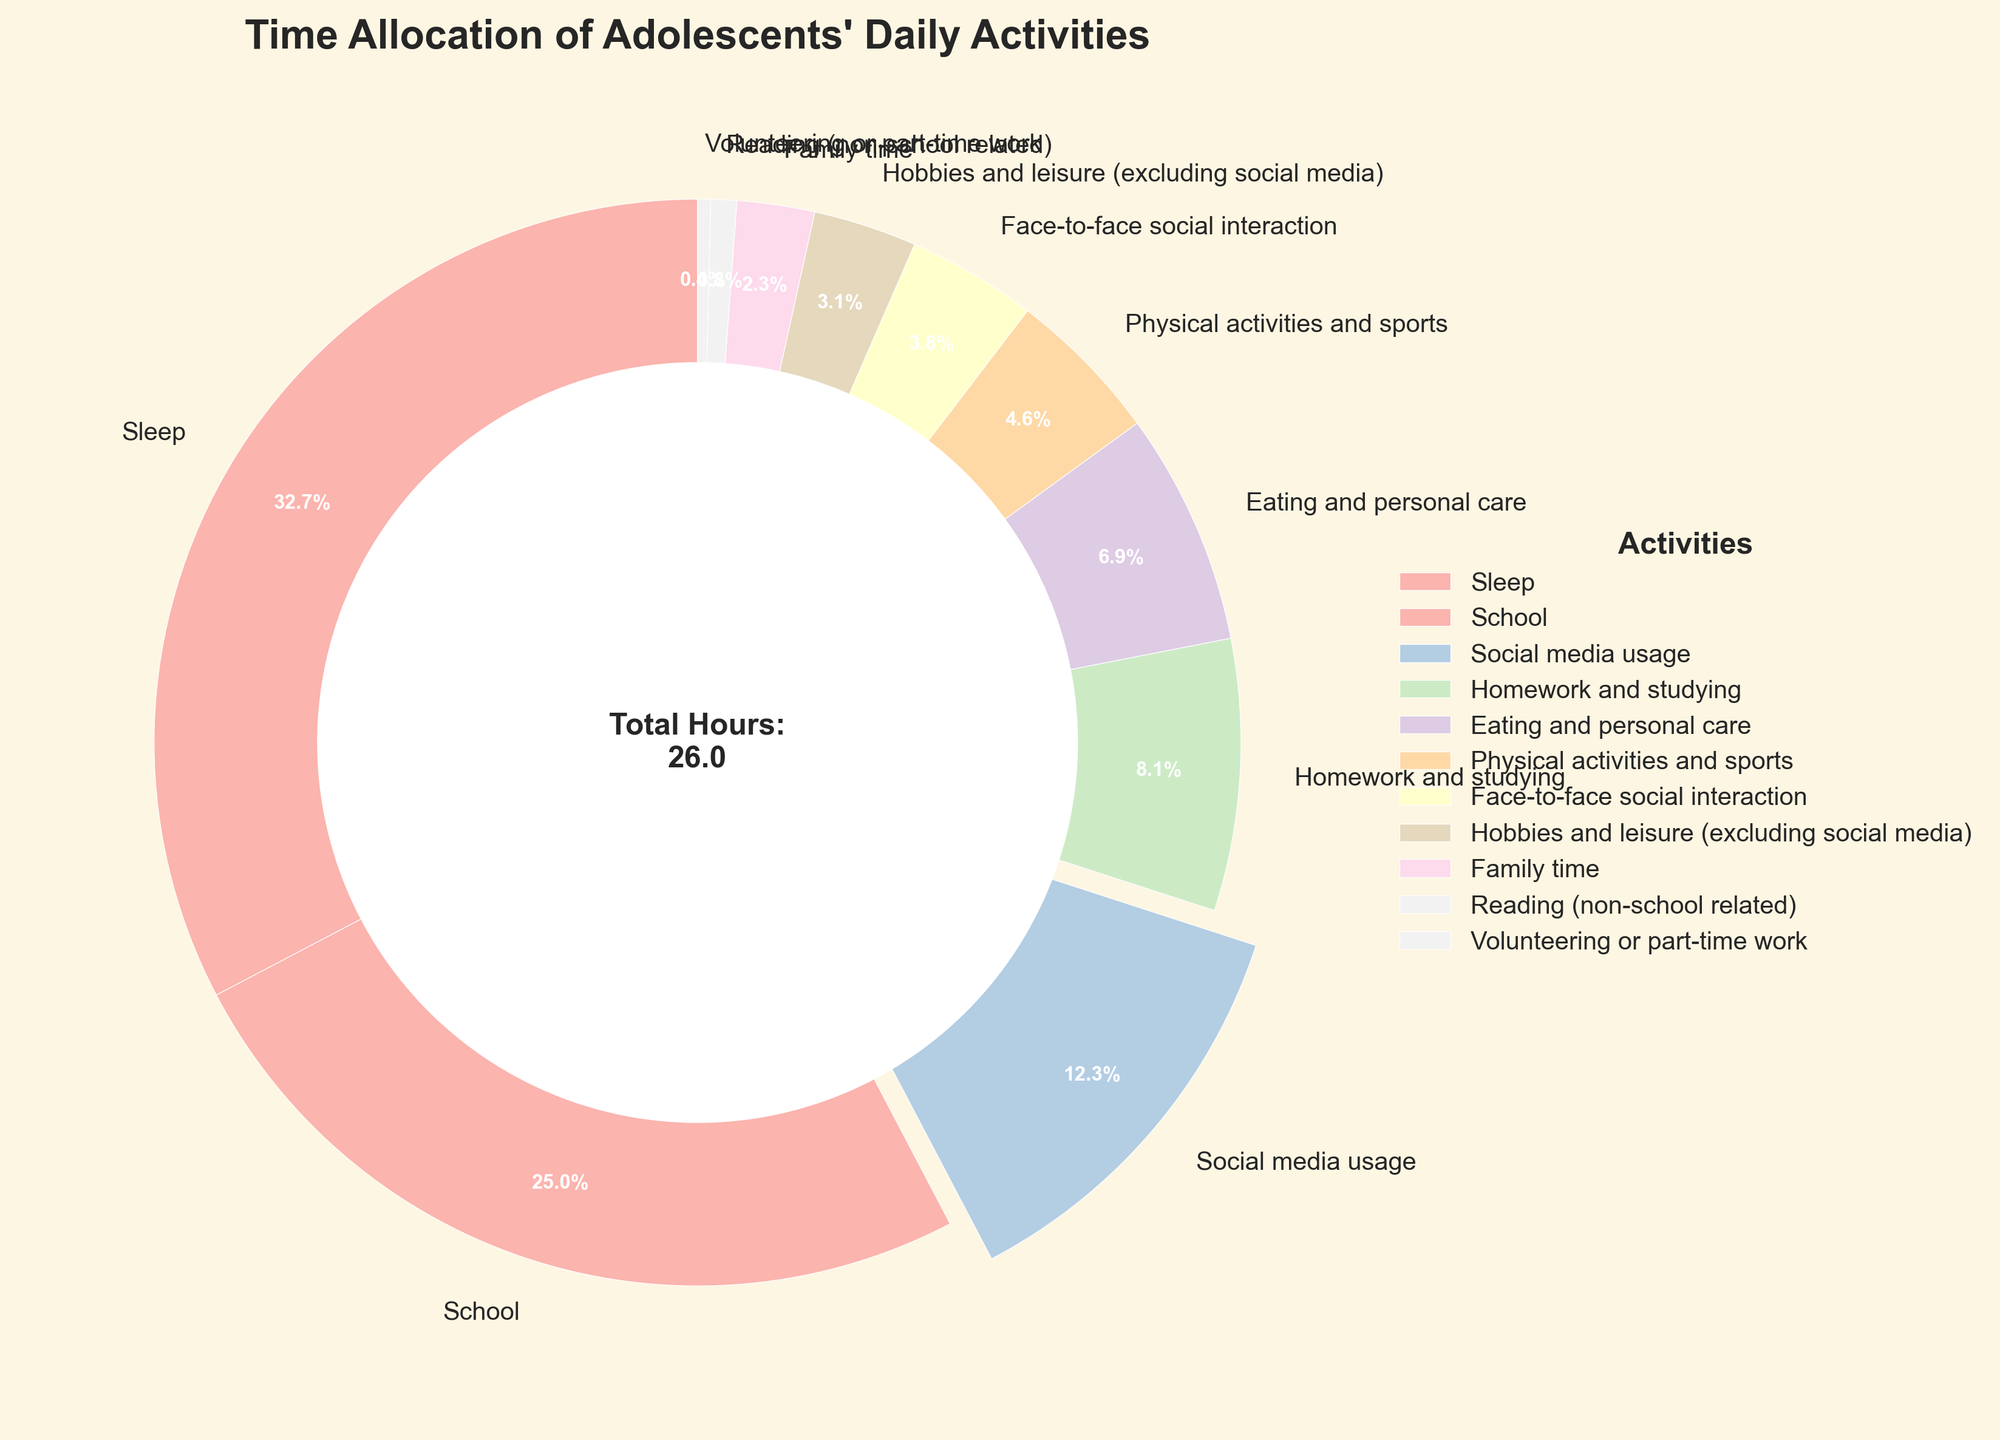What percentage of time is allocated to sleep? Sleep takes up 8.5 hours of the total 25 hours (sum of all activities). The percentage is calculated as (8.5 / 25) * 100 = 34%.
Answer: 34% How does the time spent on social media usage compare to time spent on homework and studying? Social media usage is 3.2 hours, while homework and studying is 2.1 hours. Comparing these, social media usage is greater because 3.2 > 2.1.
Answer: Social media usage is greater Which activity has the smallest allocation of time, and what is its percentage? Volunteering or part-time work has the smallest time allocation at 0.1 hours. The percentage is calculated as (0.1 / 25) * 100 = 0.4%.
Answer: Volunteering or part-time work, 0.4% What is the combined percentage of time spent on physical activities and face-to-face social interaction? Physical activities and sports take 1.2 hours, and face-to-face social interaction takes 1.0 hours. The combined time is 2.2 hours, making the percentage (2.2 / 25) * 100 = 8.8%.
Answer: 8.8% How much more time is allocated to school compared to family time, in hours? School is allocated 6.5 hours, while family time is 0.6 hours. The difference is 6.5 - 0.6 = 5.9 hours.
Answer: 5.9 hours What activities are allocated less than 1 hour, and what is their total percentage? The activities under 1 hour are Hobbies and leisure (0.8), Family time (0.6), Reading (0.2), and Volunteering or part-time work (0.1). Their total is 0.8 + 0.6 + 0.2 + 0.1 = 1.7 hours. The total percentage is (1.7 / 25) * 100 = 6.8%.
Answer: Hobbies and leisure, Family time, Reading, Volunteering or part-time work, 6.8% How does the allocation of time to sleep compare visually to that of social media usage? Sleep allocation is represented by the largest wedge in the pie chart, taking up a significantly larger segment than social media usage, which is emphasized by a slight explosion of the wedge. This visually shows that sleep time is much greater.
Answer: Sleep time is much greater What is the total time spent on activities other than sleep and school? The time spent on other activities is 25 (total time) - 8.5 (sleep) - 6.5 (school) = 10 hours.
Answer: 10 hours Which activity's time allocation is highlighted by a visual feature in the pie chart, and what is this feature? Social media usage is highlighted by being slightly exploded out from the pie chart, drawing attention to this activity.
Answer: Social media usage 